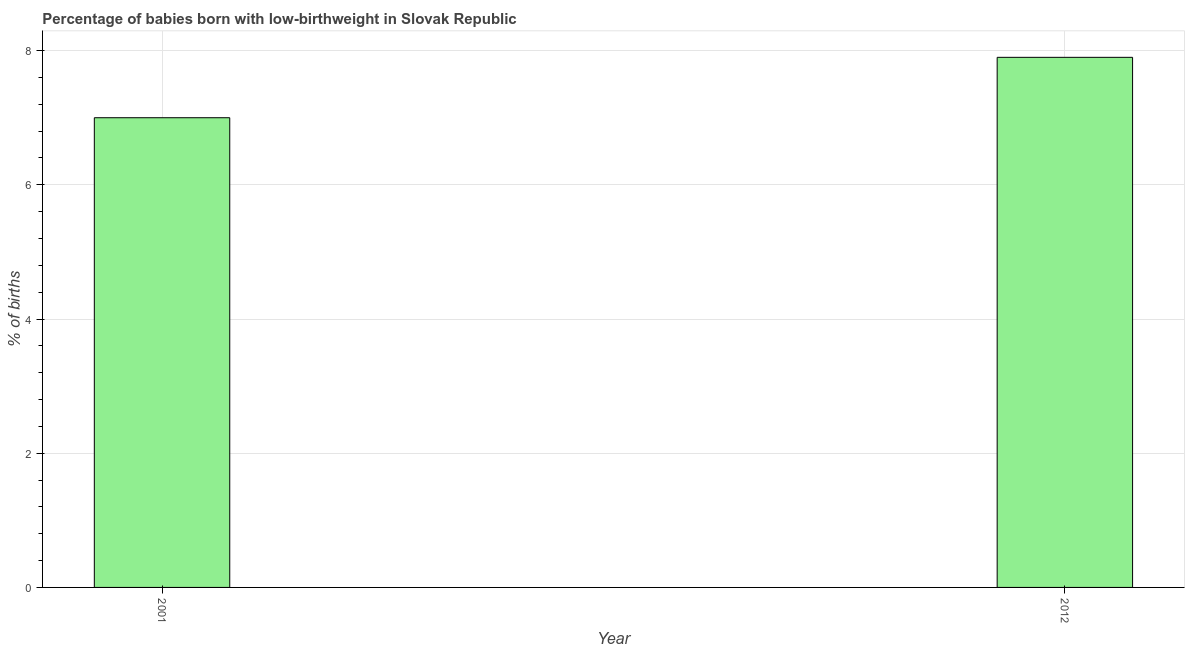Does the graph contain any zero values?
Your answer should be very brief. No. Does the graph contain grids?
Your response must be concise. Yes. What is the title of the graph?
Give a very brief answer. Percentage of babies born with low-birthweight in Slovak Republic. What is the label or title of the X-axis?
Your answer should be very brief. Year. What is the label or title of the Y-axis?
Keep it short and to the point. % of births. In which year was the percentage of babies who were born with low-birthweight maximum?
Your response must be concise. 2012. In which year was the percentage of babies who were born with low-birthweight minimum?
Offer a very short reply. 2001. What is the average percentage of babies who were born with low-birthweight per year?
Give a very brief answer. 7.45. What is the median percentage of babies who were born with low-birthweight?
Provide a succinct answer. 7.45. In how many years, is the percentage of babies who were born with low-birthweight greater than 4.8 %?
Offer a terse response. 2. What is the ratio of the percentage of babies who were born with low-birthweight in 2001 to that in 2012?
Your response must be concise. 0.89. Is the percentage of babies who were born with low-birthweight in 2001 less than that in 2012?
Your answer should be compact. Yes. In how many years, is the percentage of babies who were born with low-birthweight greater than the average percentage of babies who were born with low-birthweight taken over all years?
Make the answer very short. 1. How many bars are there?
Offer a very short reply. 2. How many years are there in the graph?
Provide a short and direct response. 2. What is the difference between two consecutive major ticks on the Y-axis?
Offer a very short reply. 2. What is the % of births of 2001?
Offer a terse response. 7. What is the % of births of 2012?
Your answer should be compact. 7.9. What is the ratio of the % of births in 2001 to that in 2012?
Provide a short and direct response. 0.89. 